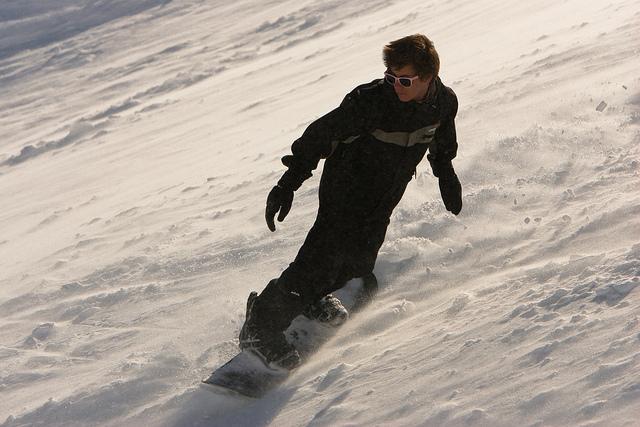What season is it in this scene?
Give a very brief answer. Winter. What are on the people's feet?
Short answer required. Boots. What is the person holding in their hands?
Concise answer only. Nothing. Is this man using a snowboard?
Quick response, please. Yes. What kind of sport is this?
Write a very short answer. Snowboarding. Is the person tired?
Keep it brief. No. What is this man doing?
Concise answer only. Snowboarding. What is the man doing?
Answer briefly. Snowboarding. What is over the man's eyes?
Write a very short answer. Sunglasses. What is on the person's face?
Short answer required. Sunglasses. 